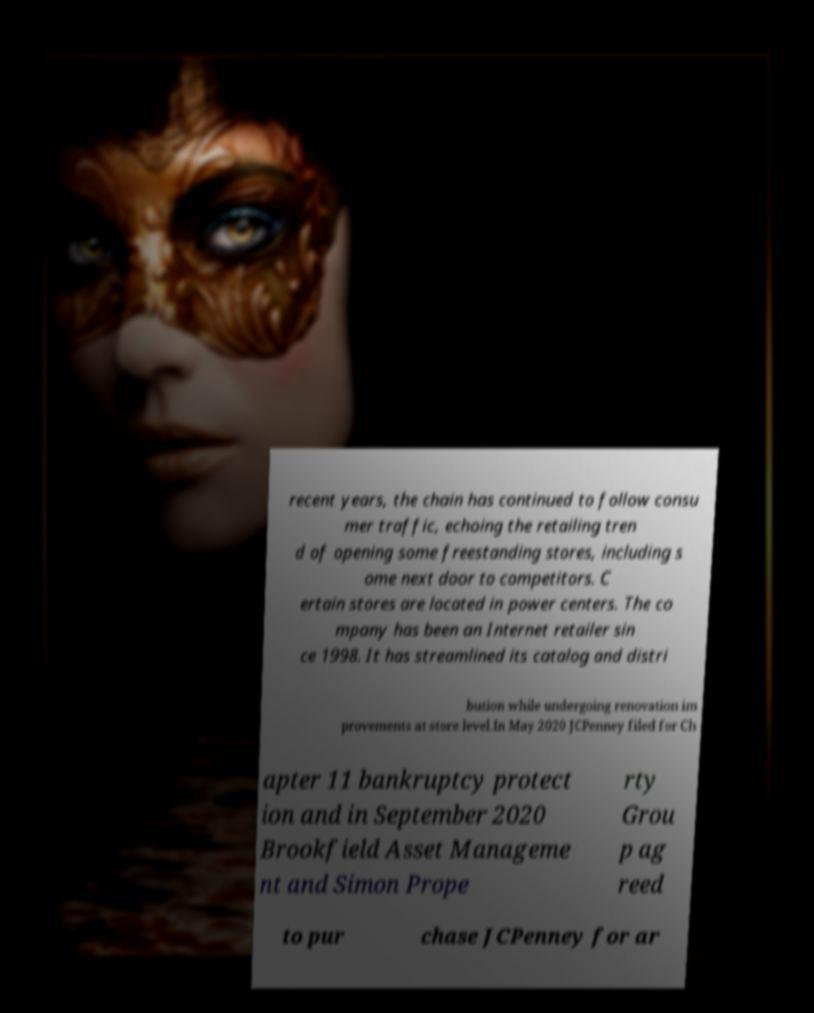There's text embedded in this image that I need extracted. Can you transcribe it verbatim? recent years, the chain has continued to follow consu mer traffic, echoing the retailing tren d of opening some freestanding stores, including s ome next door to competitors. C ertain stores are located in power centers. The co mpany has been an Internet retailer sin ce 1998. It has streamlined its catalog and distri bution while undergoing renovation im provements at store level.In May 2020 JCPenney filed for Ch apter 11 bankruptcy protect ion and in September 2020 Brookfield Asset Manageme nt and Simon Prope rty Grou p ag reed to pur chase JCPenney for ar 